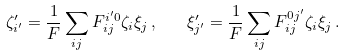Convert formula to latex. <formula><loc_0><loc_0><loc_500><loc_500>\zeta _ { i ^ { \prime } } ^ { \prime } = \frac { 1 } { F } \sum _ { i j } F _ { i j } ^ { i ^ { \prime } 0 } \zeta _ { i } \xi _ { j } \, , \quad \xi _ { j ^ { \prime } } ^ { \prime } = \frac { 1 } { F } \sum _ { i j } F _ { i j } ^ { 0 j ^ { \prime } } \zeta _ { i } \xi _ { j } \, .</formula> 